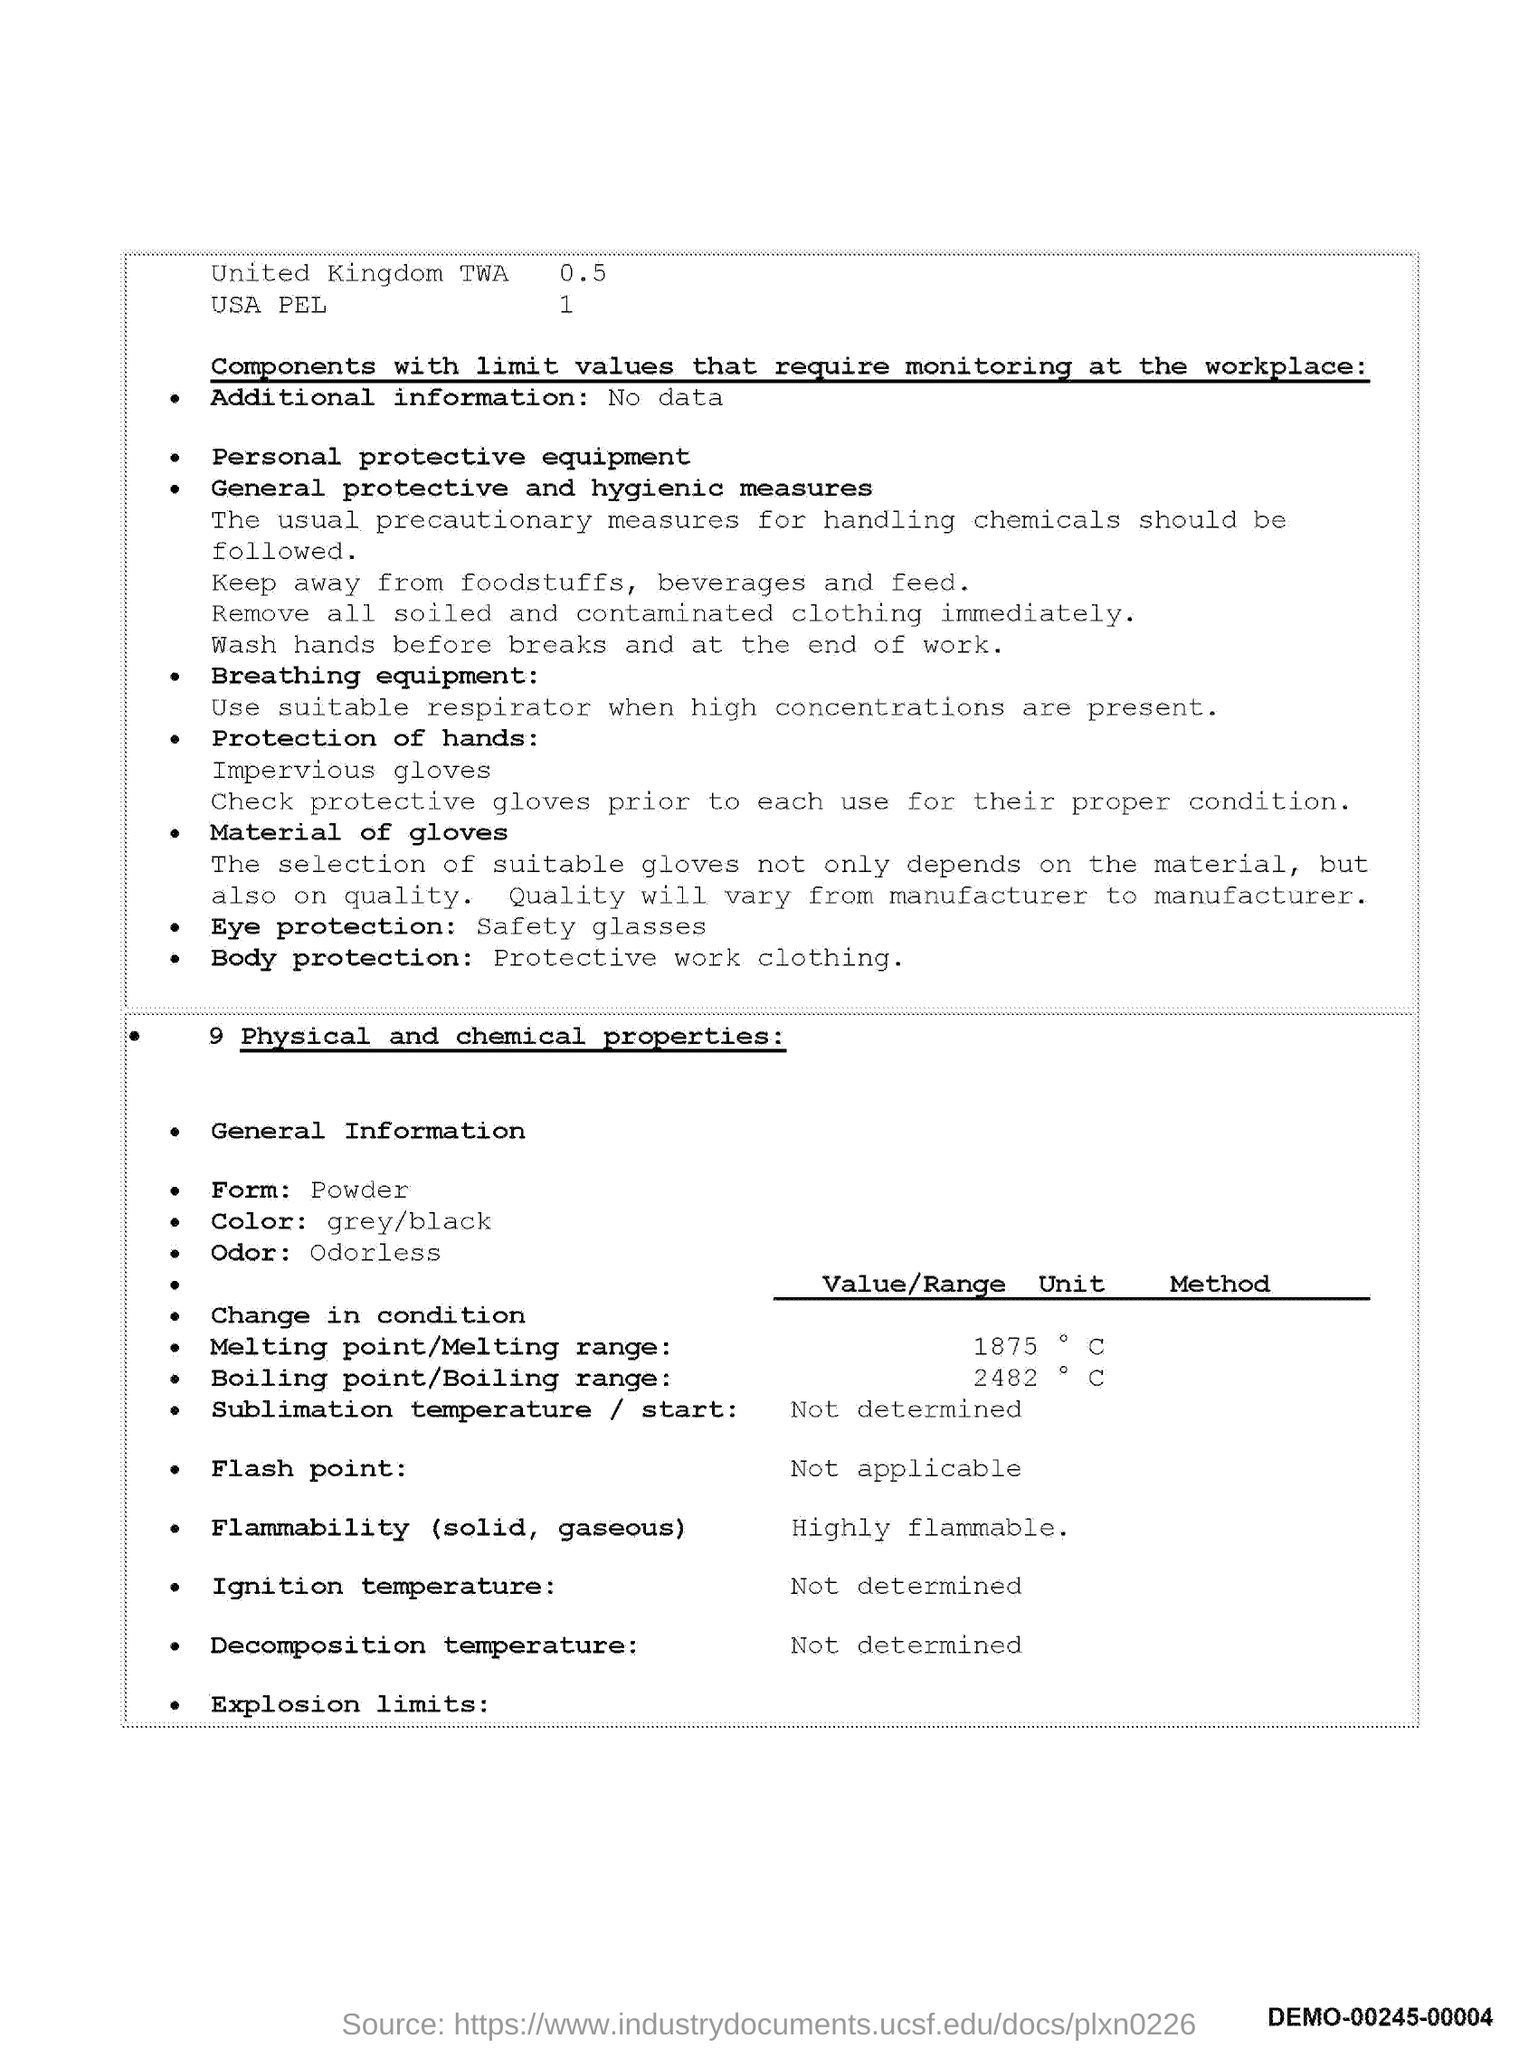What is the color mentioned in the document??
Ensure brevity in your answer.  Grey/black. In which form the material is available?
Offer a very short reply. Powder. What is the melting point value?
Your response must be concise. 1875. What is the boiling point value?
Offer a very short reply. 2482. 